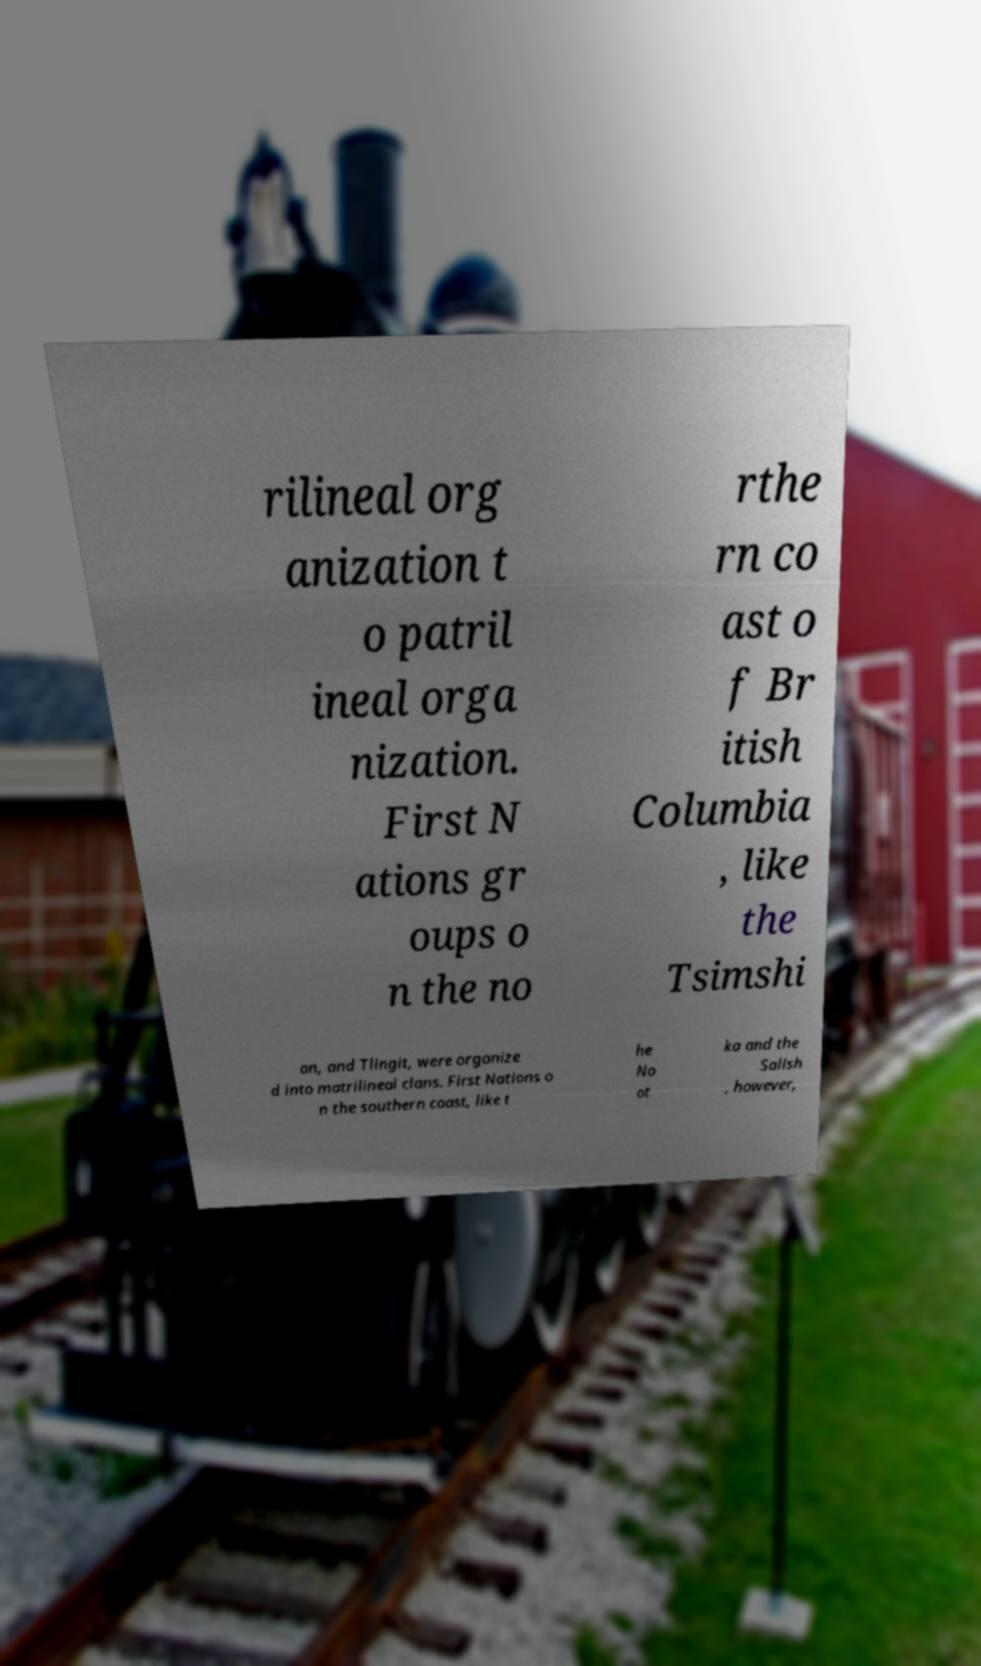Please identify and transcribe the text found in this image. rilineal org anization t o patril ineal orga nization. First N ations gr oups o n the no rthe rn co ast o f Br itish Columbia , like the Tsimshi an, and Tlingit, were organize d into matrilineal clans. First Nations o n the southern coast, like t he No ot ka and the Salish , however, 